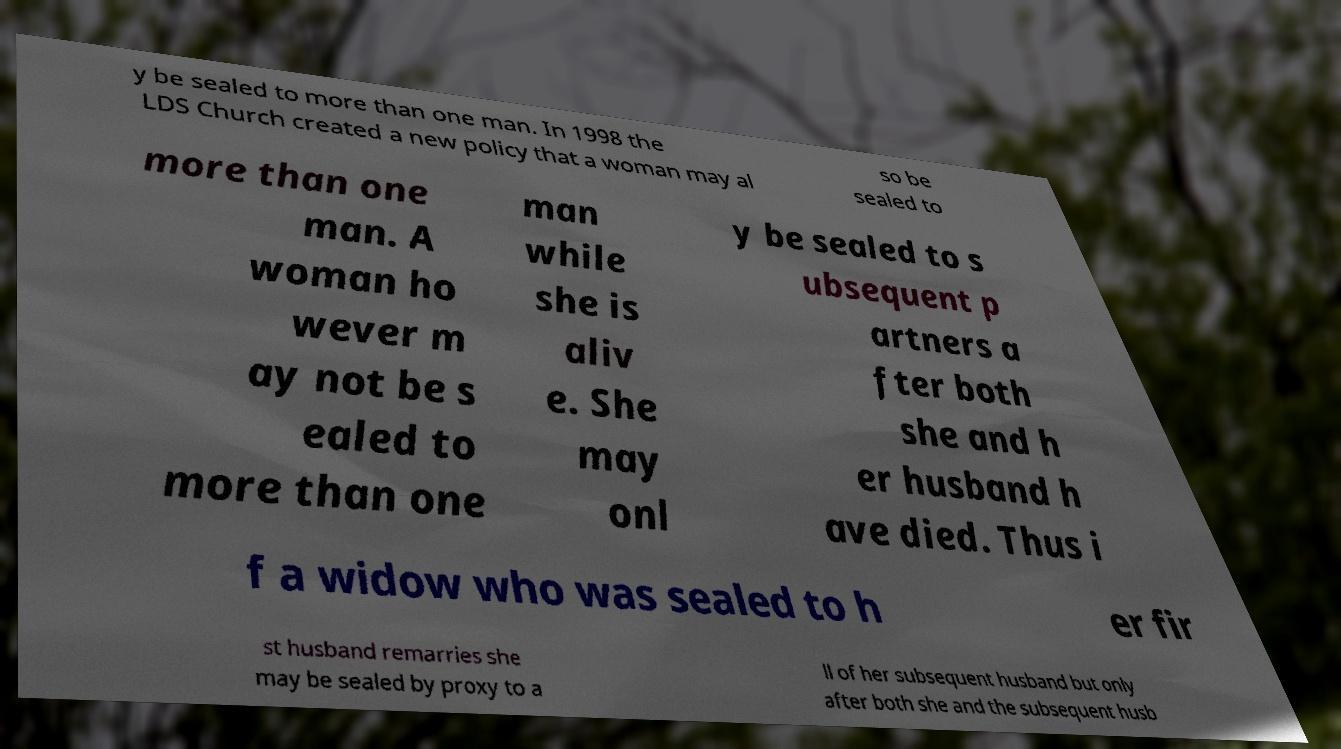What messages or text are displayed in this image? I need them in a readable, typed format. y be sealed to more than one man. In 1998 the LDS Church created a new policy that a woman may al so be sealed to more than one man. A woman ho wever m ay not be s ealed to more than one man while she is aliv e. She may onl y be sealed to s ubsequent p artners a fter both she and h er husband h ave died. Thus i f a widow who was sealed to h er fir st husband remarries she may be sealed by proxy to a ll of her subsequent husband but only after both she and the subsequent husb 